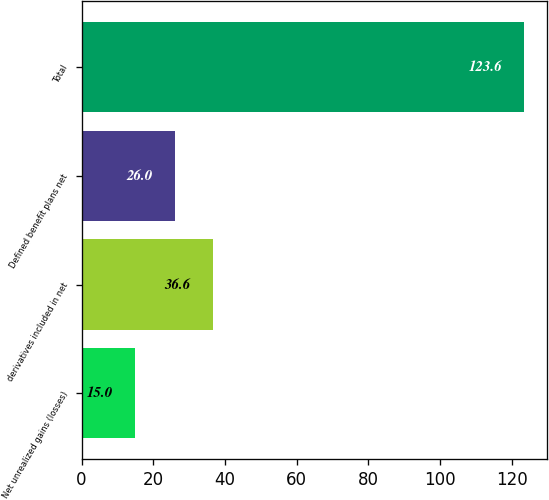<chart> <loc_0><loc_0><loc_500><loc_500><bar_chart><fcel>Net unrealized gains (losses)<fcel>derivatives included in net<fcel>Defined benefit plans net<fcel>Total<nl><fcel>15<fcel>36.6<fcel>26<fcel>123.6<nl></chart> 